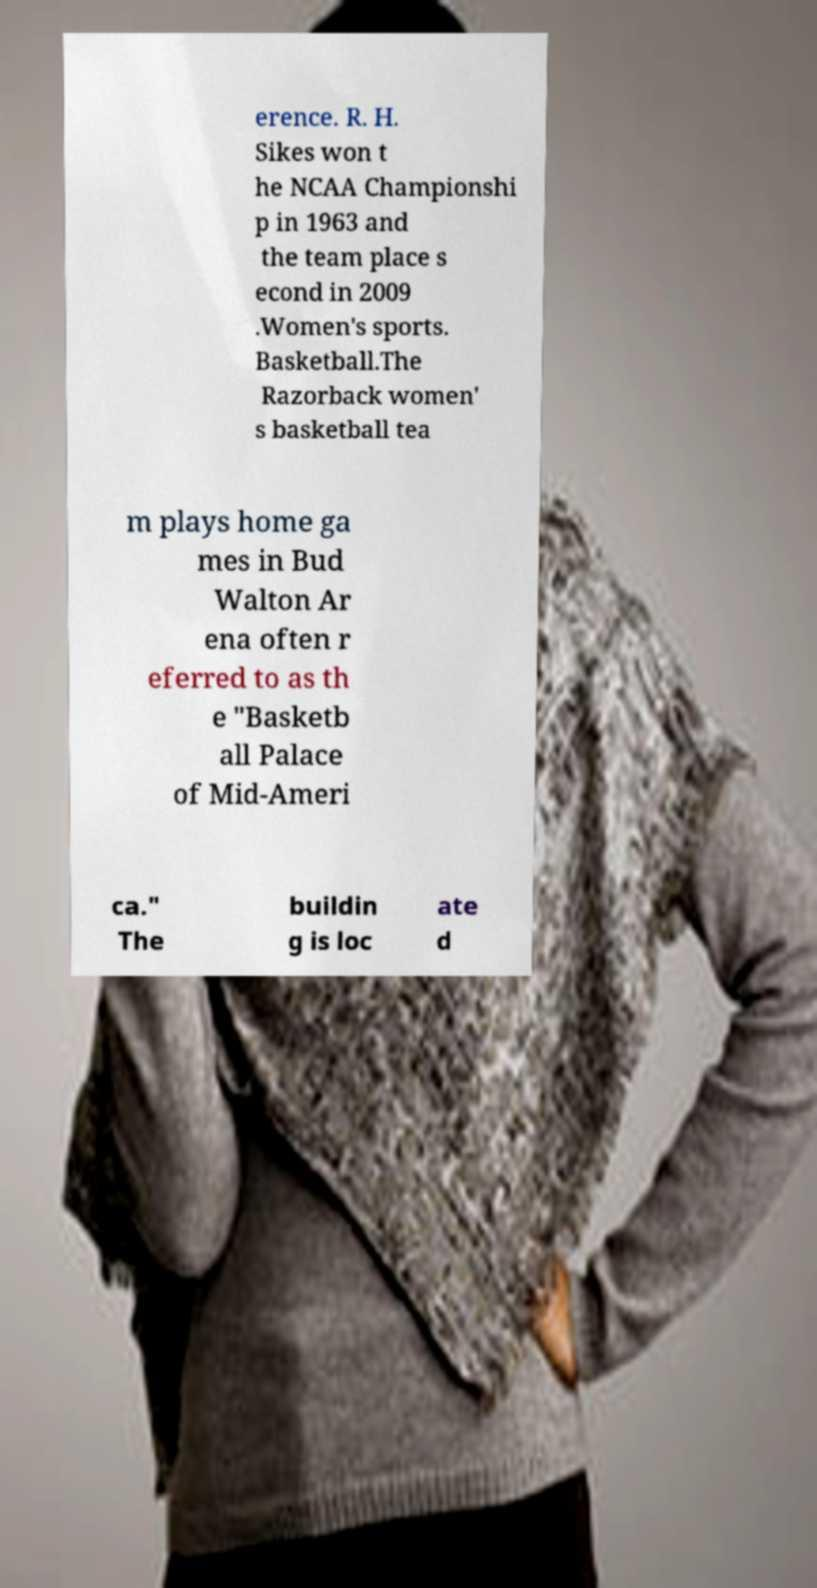Can you accurately transcribe the text from the provided image for me? erence. R. H. Sikes won t he NCAA Championshi p in 1963 and the team place s econd in 2009 .Women's sports. Basketball.The Razorback women' s basketball tea m plays home ga mes in Bud Walton Ar ena often r eferred to as th e "Basketb all Palace of Mid-Ameri ca." The buildin g is loc ate d 